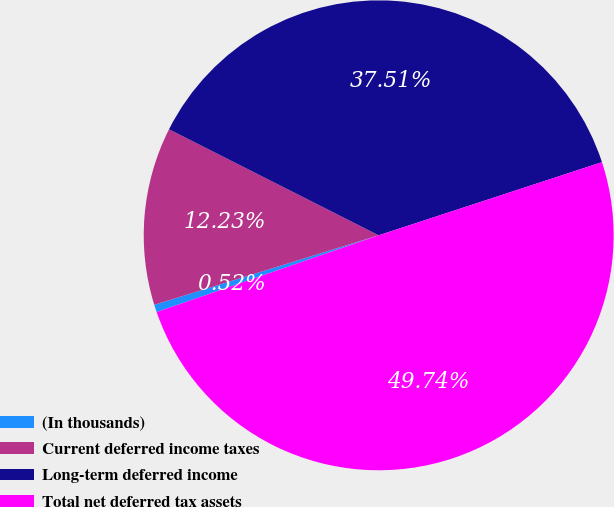Convert chart. <chart><loc_0><loc_0><loc_500><loc_500><pie_chart><fcel>(In thousands)<fcel>Current deferred income taxes<fcel>Long-term deferred income<fcel>Total net deferred tax assets<nl><fcel>0.52%<fcel>12.23%<fcel>37.51%<fcel>49.74%<nl></chart> 